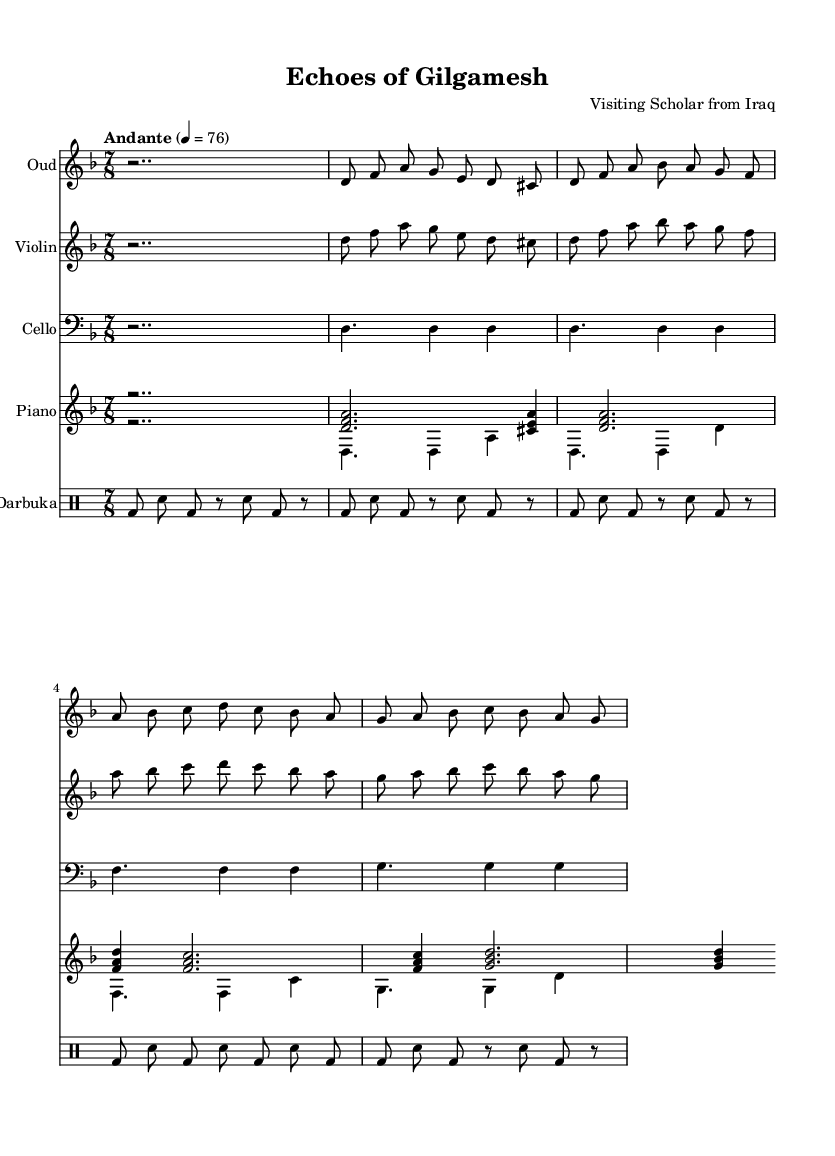What is the key signature of this music? The key signature indicates the use of the D minor scale, which has one flat (B flat) in its key signature. This can be confirmed by looking at the key signature listed at the beginning of the staff symbols.
Answer: D minor What is the time signature of this music? The time signature shown in the sheet music is 7/8, which can be observed placed at the beginning of the score. This indicates that each measure contains seven eighth-note beats.
Answer: 7/8 What is the tempo marking in this piece? The tempo marking provided in the sheet music is "Andante," which denotes a moderately slow tempo. The exact BPM for "Andante" can vary, but in this instance, it is specified as 4 = 76, indicating the beats per minute.
Answer: Andante How many measures are indicated for the oud part? By counting the measures in the oud staff, there are a total of four measures displayed in the music, represented by the bar lines that separate the rhythmic units.
Answer: 4 Which instrument is playing rhythmic patterns typical of Arabic music? The instrument that plays the darbuka, known for its distinct rhythmic patterns common in Arabic music, is indicated in the drum staff. The patterns reflect traditional Middle Eastern rhythmic styles.
Answer: Darbuka What form does this composition primarily take? The structure of the piece consists of multiple instrumental parts playing complementary melodies and rhythms, which is characteristic of chamber music. This can be seen in how each instrument interacts within the score.
Answer: Chamber music 